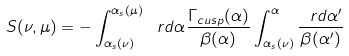Convert formula to latex. <formula><loc_0><loc_0><loc_500><loc_500>S ( \nu , \mu ) = - \int _ { \alpha _ { s } ( \nu ) } ^ { \alpha _ { s } ( \mu ) } \ r d \alpha \frac { \Gamma _ { c u s p } ( \alpha ) } { \beta ( \alpha ) } \int _ { \alpha _ { s } ( \nu ) } ^ { \alpha } \frac { \ r d \alpha ^ { \prime } } { \beta ( \alpha ^ { \prime } ) }</formula> 